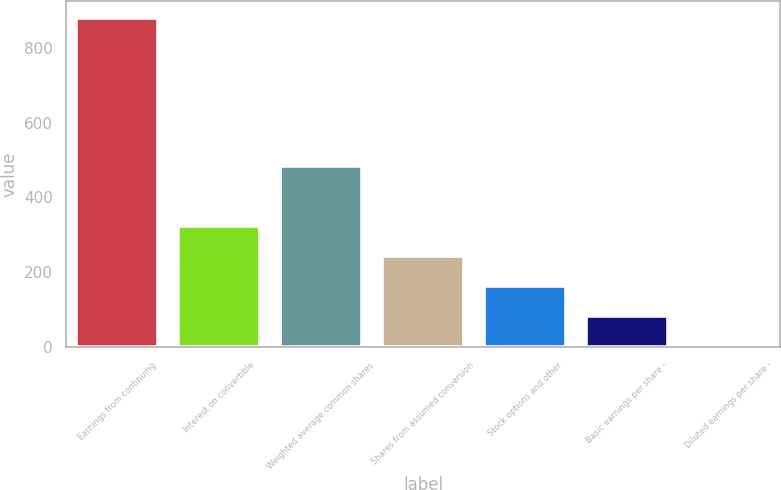Convert chart to OTSL. <chart><loc_0><loc_0><loc_500><loc_500><bar_chart><fcel>Earnings from continuing<fcel>Interest on convertible<fcel>Weighted average common shares<fcel>Shares from assumed conversion<fcel>Stock options and other<fcel>Basic earnings per share -<fcel>Diluted earnings per share -<nl><fcel>880.36<fcel>323.85<fcel>484.57<fcel>243.49<fcel>163.13<fcel>82.77<fcel>2.41<nl></chart> 